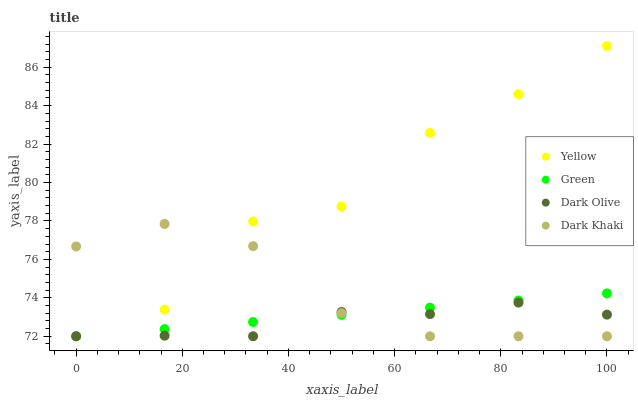Does Dark Olive have the minimum area under the curve?
Answer yes or no. Yes. Does Yellow have the maximum area under the curve?
Answer yes or no. Yes. Does Green have the minimum area under the curve?
Answer yes or no. No. Does Green have the maximum area under the curve?
Answer yes or no. No. Is Green the smoothest?
Answer yes or no. Yes. Is Yellow the roughest?
Answer yes or no. Yes. Is Dark Olive the smoothest?
Answer yes or no. No. Is Dark Olive the roughest?
Answer yes or no. No. Does Dark Khaki have the lowest value?
Answer yes or no. Yes. Does Yellow have the highest value?
Answer yes or no. Yes. Does Green have the highest value?
Answer yes or no. No. Does Dark Khaki intersect Green?
Answer yes or no. Yes. Is Dark Khaki less than Green?
Answer yes or no. No. Is Dark Khaki greater than Green?
Answer yes or no. No. 